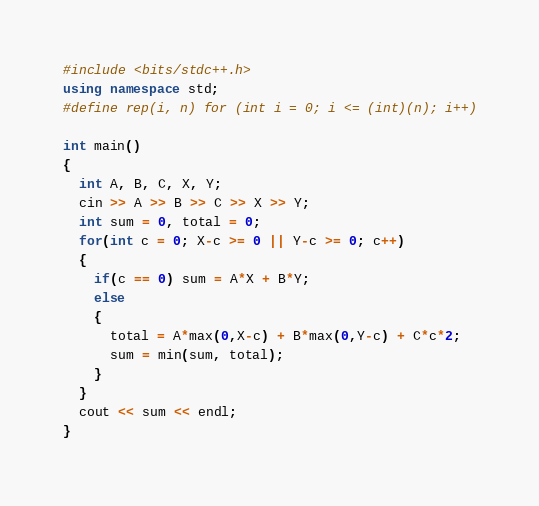Convert code to text. <code><loc_0><loc_0><loc_500><loc_500><_C++_>#include <bits/stdc++.h>
using namespace std;
#define rep(i, n) for (int i = 0; i <= (int)(n); i++)

int main()
{
  int A, B, C, X, Y;
  cin >> A >> B >> C >> X >> Y;
  int sum = 0, total = 0;
  for(int c = 0; X-c >= 0 || Y-c >= 0; c++)
  {
    if(c == 0) sum = A*X + B*Y;
    else
    {
      total = A*max(0,X-c) + B*max(0,Y-c) + C*c*2;
      sum = min(sum, total);
    }
  }
  cout << sum << endl;
}</code> 